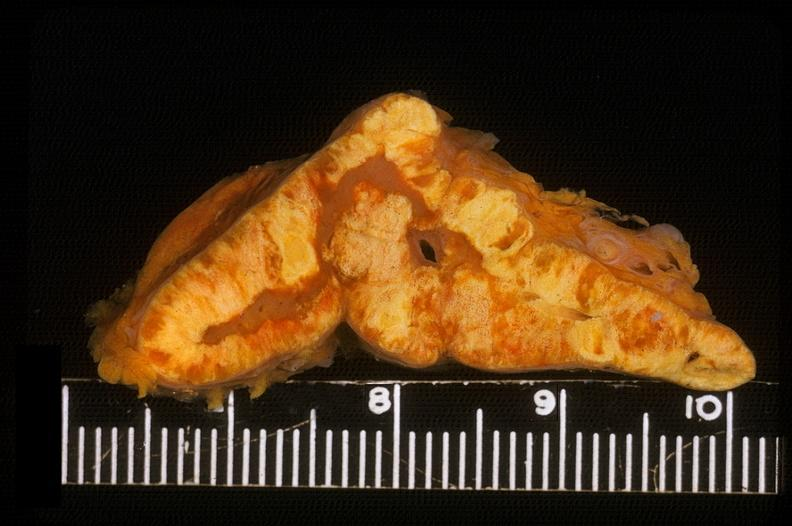what is present?
Answer the question using a single word or phrase. Endocrine 